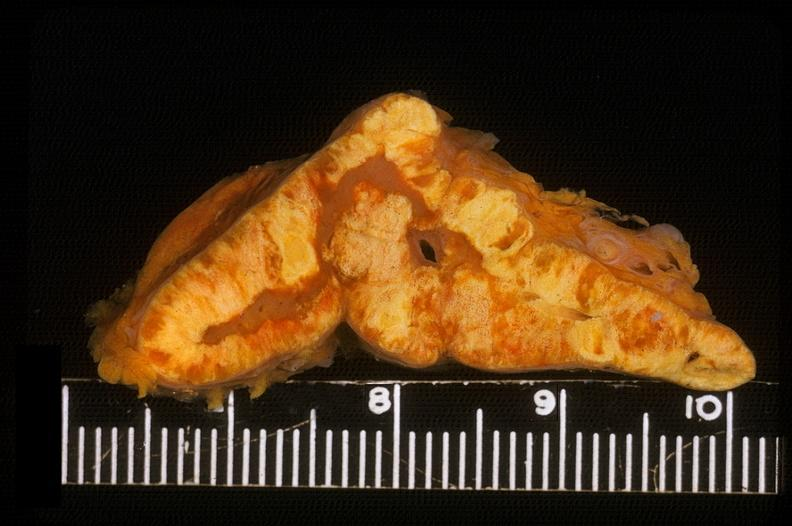what is present?
Answer the question using a single word or phrase. Endocrine 